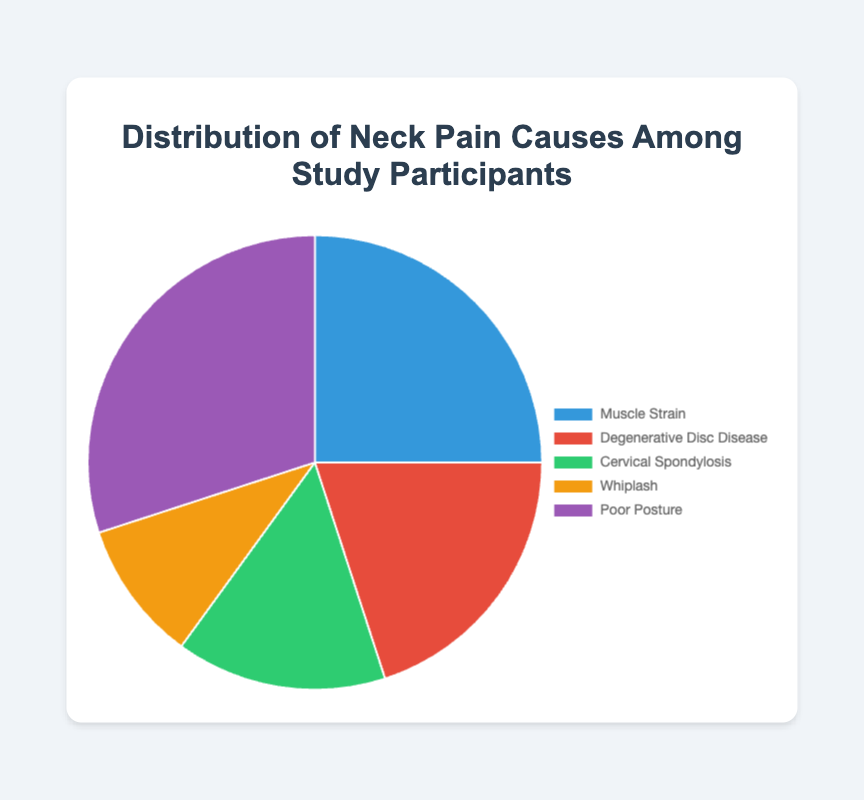Which cause of neck pain has the highest percentage among study participants? The cause with the highest percentage among the study participants is "Poor Posture" with 30%.
Answer: Poor Posture What is the total percentage for Muscle Strain and Cervical Spondylosis combined? Muscle Strain has 25% and Cervical Spondylosis has 15%. Summing these two percentages, 25% + 15% = 40%.
Answer: 40% Which cause of neck pain is less common: Whiplash or Degenerative Disc Disease? Whiplash is less common with 10% compared to Degenerative Disc Disease which has 20%.
Answer: Whiplash How much more common is Poor Posture compared to Whiplash? Poor Posture accounts for 30% while Whiplash accounts for 10%. The difference is 30% - 10% = 20%.
Answer: 20% What is the average percentage of the given causes of neck pain? To find the average, sum all the percentages and then divide by the number of causes. The sum is 25% + 20% + 15% + 10% + 30% = 100%. There are 5 causes, so average is 100% / 5 = 20%.
Answer: 20% Are there more participants suffering from Poor Posture than from Muscle Strain and Whiplash combined? Poor Posture accounts for 30%. Muscle Strain and Whiplash combined account for 25% + 10% = 35%. Therefore, there are fewer participants suffering from Poor Posture compared to Muscle Strain and Whiplash combined.
Answer: No Which cause of neck pain is represented by the green section of the pie chart? The green section of the pie chart represents Cervical Spondylosis.
Answer: Cervical Spondylosis What proportion of participants reported causes of neck pain related to posture (Poor Posture) or muscle issues (Muscle Strain)? Poor Posture accounts for 30% and Muscle Strain accounts for 25%. Therefore, the combined proportion is 30% + 25% = 55%.
Answer: 55% Is Degenerative Disc Disease more common than Cervical Spondylosis? Degenerative Disc Disease is more common with 20% compared to Cervical Spondylosis’s 15%.
Answer: Yes 